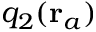Convert formula to latex. <formula><loc_0><loc_0><loc_500><loc_500>q _ { 2 } ( r _ { a } )</formula> 